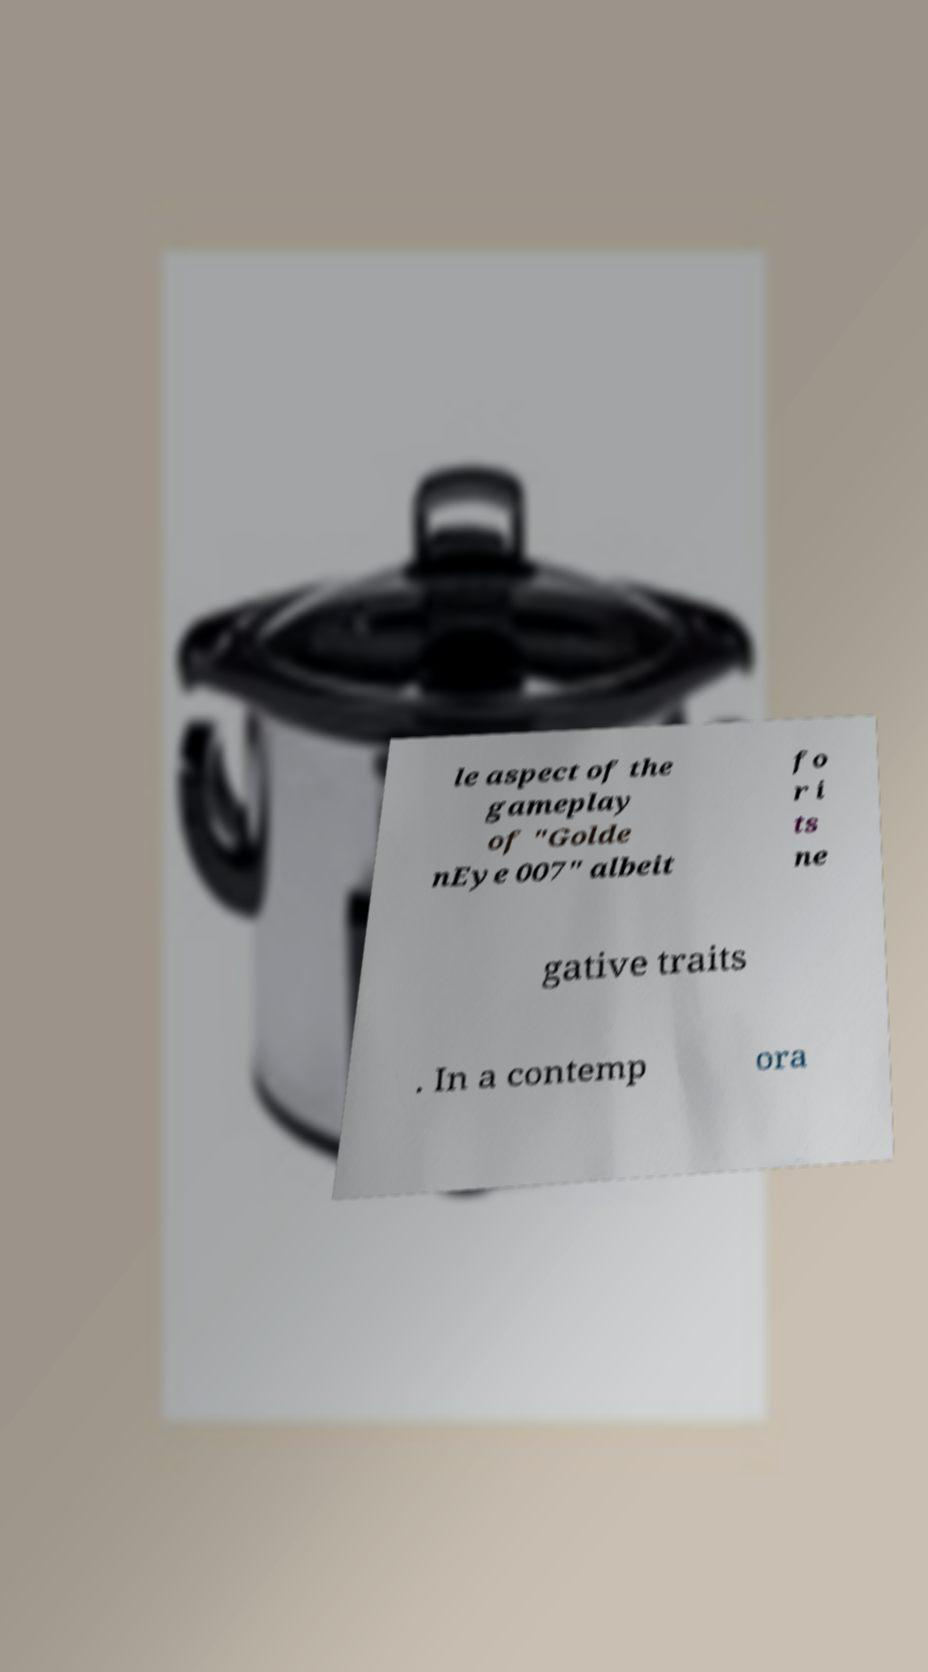For documentation purposes, I need the text within this image transcribed. Could you provide that? le aspect of the gameplay of "Golde nEye 007" albeit fo r i ts ne gative traits . In a contemp ora 